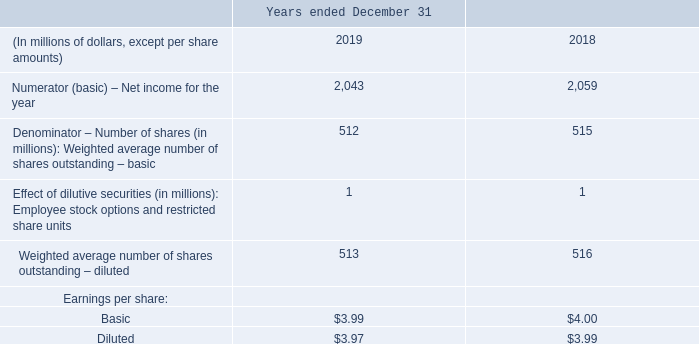EXPLANATORY INFORMATION
For the years ended December 31, 2019 and 2018, accounting for outstanding share-based payments using the equity-settled method for stock-based compensation was determined to be more dilutive than using the cash-settled method. As a result, net income for the year ended December 31, 2019 was reduced by $6 million (2018 – $2 million) in the diluted earnings per share calculation.
For the year ended December 31, 2019, there were 1,077,875 options out of the money (2018 – 37,715) for purposes of the calculation of earnings per share. These options were excluded from the calculation of the effect of dilutive securities because they were anti-dilutive.
Which accounting for outstanding share-based payments method was determined to be dilutive? Accounting for outstanding share-based payments using the equity-settled method for stock-based compensation was determined to be more dilutive than using the cash-settled method. How much did the net income reduced for the year ended December 31, 2019? Net income for the year ended december 31, 2019 was reduced by $6 million (2018 – $2 million) in the diluted earnings per share calculation. For the year ended December 31, 2019, how much was the options out of the money for purposes of the calculation of earnings per share? For the year ended december 31, 2019, there were 1,077,875 options out of the money (2018 – 37,715) for purposes of the calculation of earnings per share. What is the increase/ (decrease) in Numerator (basic) – Net income from 2018 to 2019?
Answer scale should be: million. 2,043-2,059 
Answer: -16. What is the increase/ (decrease) in Basic Earnings per share from 2018 to 2019? 3.99-4.00
Answer: -0.01. What is the increase/ (decrease) in Diluted Earnings per share from 2018 to 2019? 3.97-3.99
Answer: -0.02. 